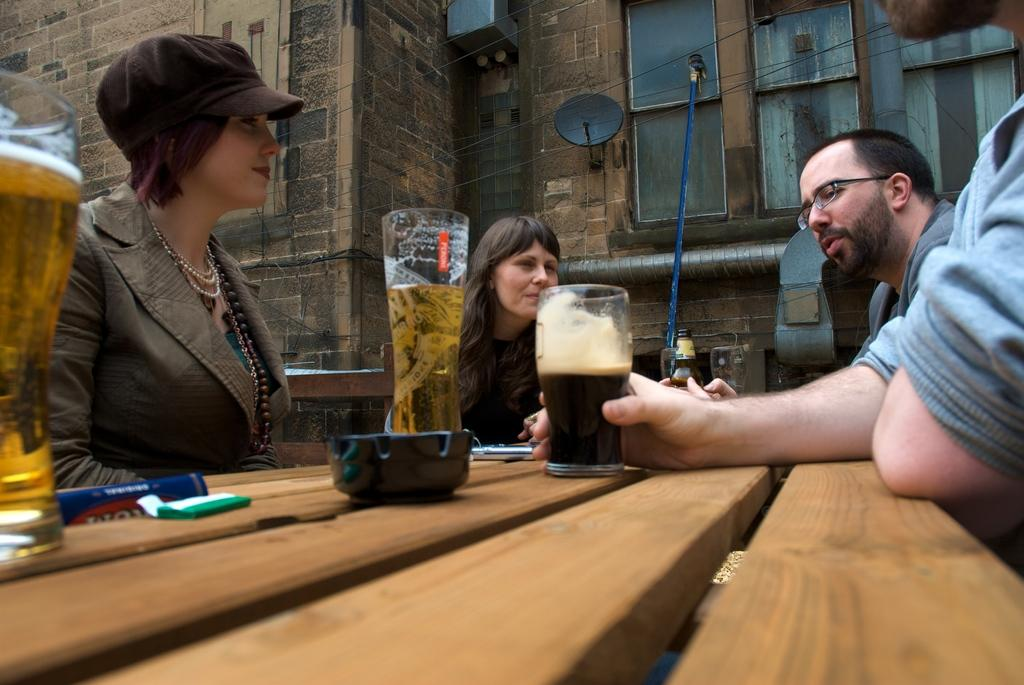What are the people in the image doing? The people in the image are sitting around a table. What are the people holding in their hands? The people are holding glasses of drinks. What type of drink is in the glasses? The people are holding glasses of beer. What type of appliance can be seen in the background of the image? There is no appliance visible in the image; it only shows people sitting around a table holding glasses of beer. 